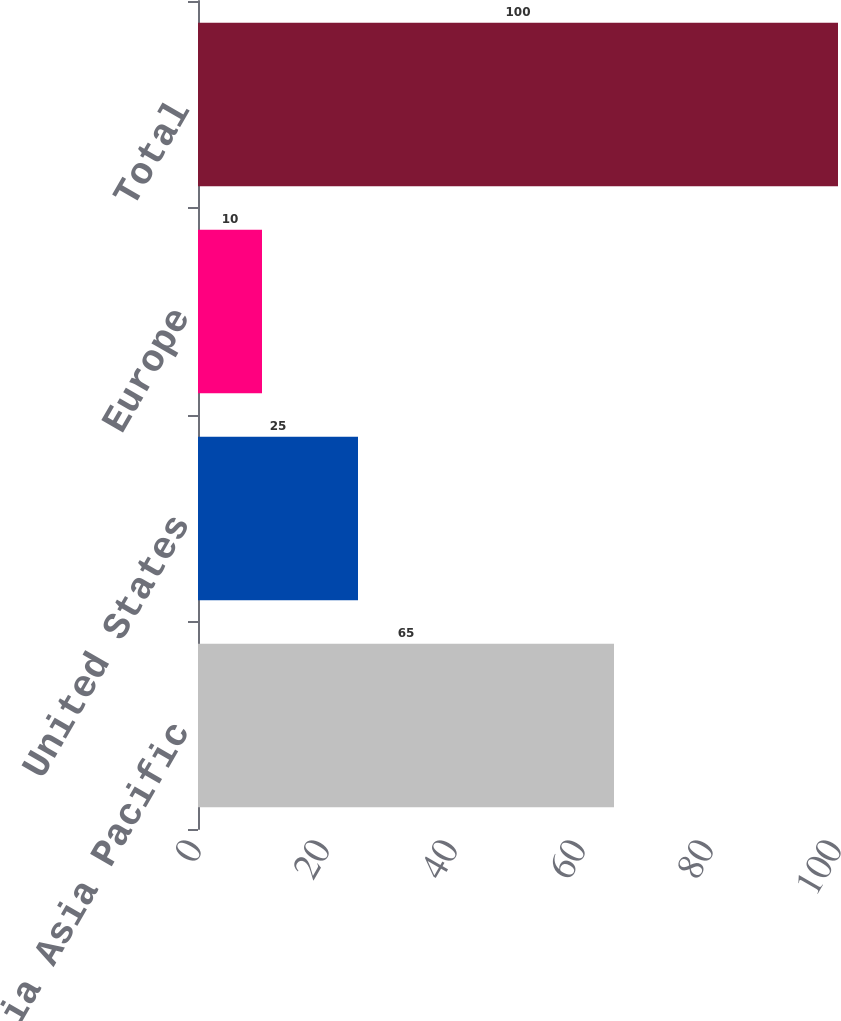Convert chart. <chart><loc_0><loc_0><loc_500><loc_500><bar_chart><fcel>Southeast Asia Asia Pacific<fcel>United States<fcel>Europe<fcel>Total<nl><fcel>65<fcel>25<fcel>10<fcel>100<nl></chart> 